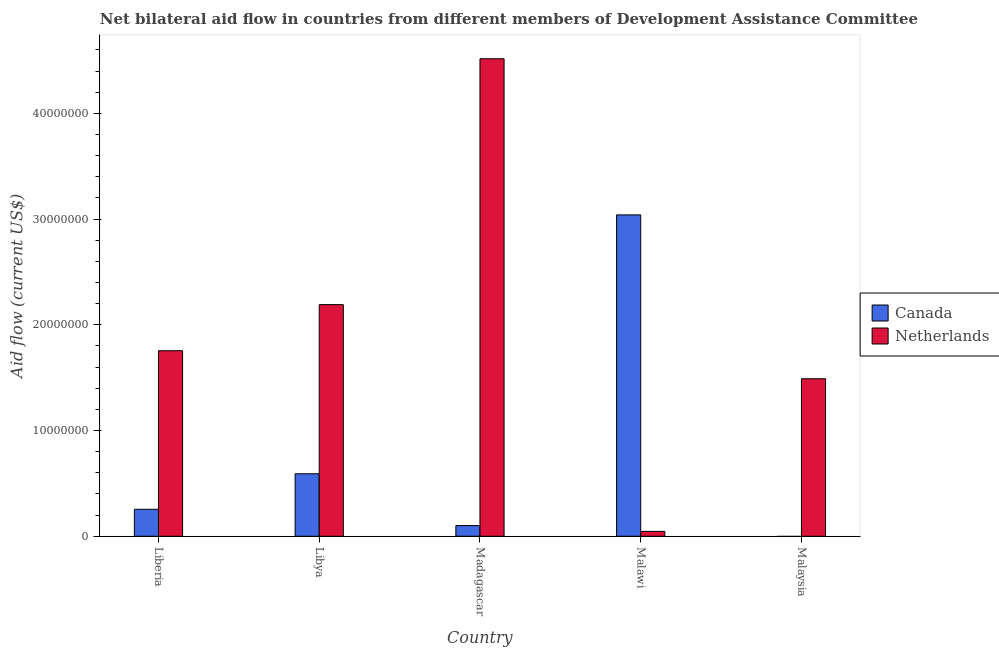How many different coloured bars are there?
Give a very brief answer. 2. How many bars are there on the 5th tick from the right?
Provide a succinct answer. 2. What is the label of the 4th group of bars from the left?
Keep it short and to the point. Malawi. What is the amount of aid given by netherlands in Madagascar?
Ensure brevity in your answer.  4.52e+07. Across all countries, what is the maximum amount of aid given by canada?
Ensure brevity in your answer.  3.04e+07. Across all countries, what is the minimum amount of aid given by netherlands?
Provide a succinct answer. 4.60e+05. In which country was the amount of aid given by canada maximum?
Provide a succinct answer. Malawi. What is the total amount of aid given by netherlands in the graph?
Give a very brief answer. 1.00e+08. What is the difference between the amount of aid given by canada in Liberia and that in Madagascar?
Offer a very short reply. 1.54e+06. What is the difference between the amount of aid given by netherlands in Malawi and the amount of aid given by canada in Liberia?
Offer a very short reply. -2.09e+06. What is the average amount of aid given by canada per country?
Give a very brief answer. 7.97e+06. What is the difference between the amount of aid given by canada and amount of aid given by netherlands in Malawi?
Provide a succinct answer. 2.99e+07. What is the ratio of the amount of aid given by netherlands in Liberia to that in Malaysia?
Offer a terse response. 1.18. Is the amount of aid given by canada in Liberia less than that in Libya?
Keep it short and to the point. Yes. What is the difference between the highest and the second highest amount of aid given by canada?
Your response must be concise. 2.45e+07. What is the difference between the highest and the lowest amount of aid given by canada?
Ensure brevity in your answer.  3.04e+07. Is the sum of the amount of aid given by netherlands in Liberia and Libya greater than the maximum amount of aid given by canada across all countries?
Provide a short and direct response. Yes. Are all the bars in the graph horizontal?
Ensure brevity in your answer.  No. Does the graph contain grids?
Offer a very short reply. No. Where does the legend appear in the graph?
Your response must be concise. Center right. How many legend labels are there?
Your answer should be compact. 2. How are the legend labels stacked?
Your answer should be very brief. Vertical. What is the title of the graph?
Provide a short and direct response. Net bilateral aid flow in countries from different members of Development Assistance Committee. What is the label or title of the Y-axis?
Your response must be concise. Aid flow (current US$). What is the Aid flow (current US$) of Canada in Liberia?
Provide a succinct answer. 2.55e+06. What is the Aid flow (current US$) of Netherlands in Liberia?
Keep it short and to the point. 1.76e+07. What is the Aid flow (current US$) of Canada in Libya?
Keep it short and to the point. 5.91e+06. What is the Aid flow (current US$) of Netherlands in Libya?
Your response must be concise. 2.19e+07. What is the Aid flow (current US$) in Canada in Madagascar?
Provide a succinct answer. 1.01e+06. What is the Aid flow (current US$) of Netherlands in Madagascar?
Provide a short and direct response. 4.52e+07. What is the Aid flow (current US$) in Canada in Malawi?
Ensure brevity in your answer.  3.04e+07. What is the Aid flow (current US$) of Netherlands in Malawi?
Provide a succinct answer. 4.60e+05. What is the Aid flow (current US$) in Netherlands in Malaysia?
Your response must be concise. 1.49e+07. Across all countries, what is the maximum Aid flow (current US$) of Canada?
Make the answer very short. 3.04e+07. Across all countries, what is the maximum Aid flow (current US$) of Netherlands?
Keep it short and to the point. 4.52e+07. Across all countries, what is the minimum Aid flow (current US$) of Canada?
Give a very brief answer. 0. What is the total Aid flow (current US$) of Canada in the graph?
Make the answer very short. 3.99e+07. What is the total Aid flow (current US$) in Netherlands in the graph?
Provide a succinct answer. 1.00e+08. What is the difference between the Aid flow (current US$) of Canada in Liberia and that in Libya?
Your answer should be very brief. -3.36e+06. What is the difference between the Aid flow (current US$) of Netherlands in Liberia and that in Libya?
Ensure brevity in your answer.  -4.36e+06. What is the difference between the Aid flow (current US$) of Canada in Liberia and that in Madagascar?
Make the answer very short. 1.54e+06. What is the difference between the Aid flow (current US$) of Netherlands in Liberia and that in Madagascar?
Your answer should be compact. -2.76e+07. What is the difference between the Aid flow (current US$) of Canada in Liberia and that in Malawi?
Make the answer very short. -2.78e+07. What is the difference between the Aid flow (current US$) in Netherlands in Liberia and that in Malawi?
Your answer should be very brief. 1.71e+07. What is the difference between the Aid flow (current US$) in Netherlands in Liberia and that in Malaysia?
Offer a very short reply. 2.65e+06. What is the difference between the Aid flow (current US$) of Canada in Libya and that in Madagascar?
Give a very brief answer. 4.90e+06. What is the difference between the Aid flow (current US$) in Netherlands in Libya and that in Madagascar?
Provide a short and direct response. -2.33e+07. What is the difference between the Aid flow (current US$) in Canada in Libya and that in Malawi?
Offer a very short reply. -2.45e+07. What is the difference between the Aid flow (current US$) of Netherlands in Libya and that in Malawi?
Provide a short and direct response. 2.14e+07. What is the difference between the Aid flow (current US$) of Netherlands in Libya and that in Malaysia?
Offer a very short reply. 7.01e+06. What is the difference between the Aid flow (current US$) in Canada in Madagascar and that in Malawi?
Offer a terse response. -2.94e+07. What is the difference between the Aid flow (current US$) in Netherlands in Madagascar and that in Malawi?
Ensure brevity in your answer.  4.47e+07. What is the difference between the Aid flow (current US$) in Netherlands in Madagascar and that in Malaysia?
Ensure brevity in your answer.  3.03e+07. What is the difference between the Aid flow (current US$) in Netherlands in Malawi and that in Malaysia?
Provide a short and direct response. -1.44e+07. What is the difference between the Aid flow (current US$) of Canada in Liberia and the Aid flow (current US$) of Netherlands in Libya?
Offer a very short reply. -1.94e+07. What is the difference between the Aid flow (current US$) of Canada in Liberia and the Aid flow (current US$) of Netherlands in Madagascar?
Make the answer very short. -4.26e+07. What is the difference between the Aid flow (current US$) of Canada in Liberia and the Aid flow (current US$) of Netherlands in Malawi?
Your answer should be compact. 2.09e+06. What is the difference between the Aid flow (current US$) of Canada in Liberia and the Aid flow (current US$) of Netherlands in Malaysia?
Give a very brief answer. -1.24e+07. What is the difference between the Aid flow (current US$) of Canada in Libya and the Aid flow (current US$) of Netherlands in Madagascar?
Make the answer very short. -3.93e+07. What is the difference between the Aid flow (current US$) of Canada in Libya and the Aid flow (current US$) of Netherlands in Malawi?
Offer a very short reply. 5.45e+06. What is the difference between the Aid flow (current US$) in Canada in Libya and the Aid flow (current US$) in Netherlands in Malaysia?
Your response must be concise. -8.99e+06. What is the difference between the Aid flow (current US$) in Canada in Madagascar and the Aid flow (current US$) in Netherlands in Malawi?
Provide a succinct answer. 5.50e+05. What is the difference between the Aid flow (current US$) in Canada in Madagascar and the Aid flow (current US$) in Netherlands in Malaysia?
Your response must be concise. -1.39e+07. What is the difference between the Aid flow (current US$) of Canada in Malawi and the Aid flow (current US$) of Netherlands in Malaysia?
Offer a very short reply. 1.55e+07. What is the average Aid flow (current US$) in Canada per country?
Ensure brevity in your answer.  7.97e+06. What is the average Aid flow (current US$) in Netherlands per country?
Keep it short and to the point. 2.00e+07. What is the difference between the Aid flow (current US$) in Canada and Aid flow (current US$) in Netherlands in Liberia?
Your answer should be very brief. -1.50e+07. What is the difference between the Aid flow (current US$) of Canada and Aid flow (current US$) of Netherlands in Libya?
Provide a succinct answer. -1.60e+07. What is the difference between the Aid flow (current US$) in Canada and Aid flow (current US$) in Netherlands in Madagascar?
Your answer should be compact. -4.42e+07. What is the difference between the Aid flow (current US$) in Canada and Aid flow (current US$) in Netherlands in Malawi?
Offer a very short reply. 2.99e+07. What is the ratio of the Aid flow (current US$) of Canada in Liberia to that in Libya?
Offer a very short reply. 0.43. What is the ratio of the Aid flow (current US$) of Netherlands in Liberia to that in Libya?
Provide a short and direct response. 0.8. What is the ratio of the Aid flow (current US$) of Canada in Liberia to that in Madagascar?
Keep it short and to the point. 2.52. What is the ratio of the Aid flow (current US$) of Netherlands in Liberia to that in Madagascar?
Make the answer very short. 0.39. What is the ratio of the Aid flow (current US$) in Canada in Liberia to that in Malawi?
Offer a very short reply. 0.08. What is the ratio of the Aid flow (current US$) in Netherlands in Liberia to that in Malawi?
Your response must be concise. 38.15. What is the ratio of the Aid flow (current US$) of Netherlands in Liberia to that in Malaysia?
Offer a very short reply. 1.18. What is the ratio of the Aid flow (current US$) of Canada in Libya to that in Madagascar?
Offer a very short reply. 5.85. What is the ratio of the Aid flow (current US$) in Netherlands in Libya to that in Madagascar?
Offer a very short reply. 0.49. What is the ratio of the Aid flow (current US$) of Canada in Libya to that in Malawi?
Your response must be concise. 0.19. What is the ratio of the Aid flow (current US$) of Netherlands in Libya to that in Malawi?
Ensure brevity in your answer.  47.63. What is the ratio of the Aid flow (current US$) of Netherlands in Libya to that in Malaysia?
Provide a short and direct response. 1.47. What is the ratio of the Aid flow (current US$) in Canada in Madagascar to that in Malawi?
Provide a succinct answer. 0.03. What is the ratio of the Aid flow (current US$) of Netherlands in Madagascar to that in Malawi?
Offer a very short reply. 98.2. What is the ratio of the Aid flow (current US$) of Netherlands in Madagascar to that in Malaysia?
Your response must be concise. 3.03. What is the ratio of the Aid flow (current US$) of Netherlands in Malawi to that in Malaysia?
Your answer should be compact. 0.03. What is the difference between the highest and the second highest Aid flow (current US$) of Canada?
Ensure brevity in your answer.  2.45e+07. What is the difference between the highest and the second highest Aid flow (current US$) of Netherlands?
Keep it short and to the point. 2.33e+07. What is the difference between the highest and the lowest Aid flow (current US$) in Canada?
Provide a succinct answer. 3.04e+07. What is the difference between the highest and the lowest Aid flow (current US$) in Netherlands?
Your response must be concise. 4.47e+07. 